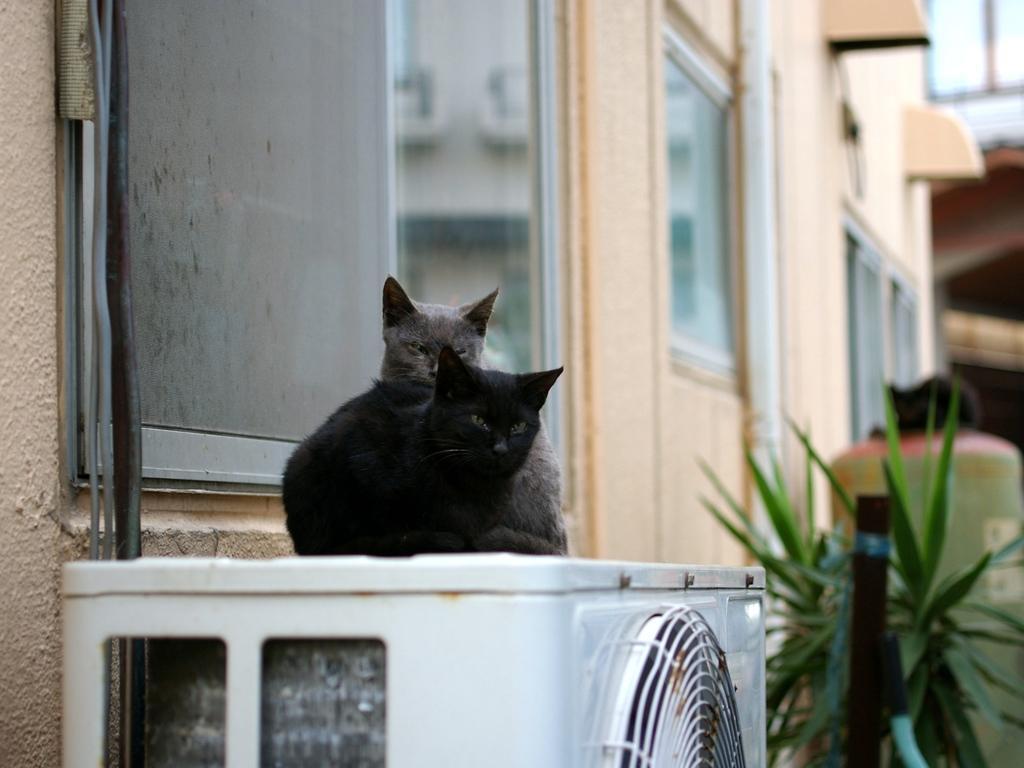What is the main object in the center of the image? There is a white color object in the center of the image. What is on top of the object? Two cats are on the object. What can be seen in the background of the image? There is a building, windows, and leaves visible in the background of the image. What type of camera can be seen in the image? There is no camera present in the image. What unit of measurement is used to describe the size of the cats in the image? The size of the cats is not described in the image, so it is not possible to determine the unit of measurement. 